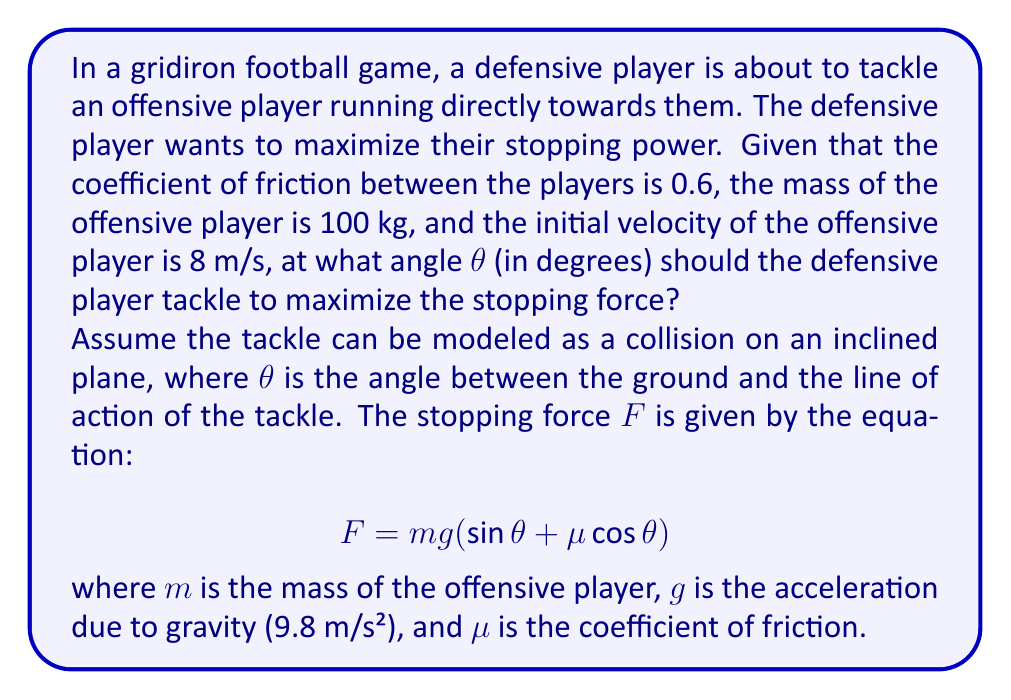Can you solve this math problem? To find the optimal angle for tackling, we need to maximize the stopping force F. We can do this by finding the angle θ where the derivative of F with respect to θ is zero.

Step 1: Express the force equation
$$ F = mg(\sin θ + μ \cos θ) $$

Step 2: Take the derivative of F with respect to θ
$$ \frac{dF}{dθ} = mg(\cos θ - μ \sin θ) $$

Step 3: Set the derivative to zero and solve for θ
$$ mg(\cos θ - μ \sin θ) = 0 $$
$$ \cos θ - μ \sin θ = 0 $$
$$ \cos θ = μ \sin θ $$
$$ \frac{\cos θ}{\sin θ} = μ $$
$$ \tan θ = \frac{1}{μ} $$

Step 4: Calculate the optimal angle
$$ θ = \arctan(\frac{1}{μ}) $$
$$ θ = \arctan(\frac{1}{0.6}) $$
$$ θ ≈ 59.04° $$

Step 5: Verify this is a maximum (not a minimum) by checking the second derivative
$$ \frac{d^2F}{dθ^2} = -mg(\sin θ + μ \cos θ) $$
At θ ≈ 59.04°, this is negative, confirming a maximum.

Therefore, the optimal angle for tackling to maximize stopping power is approximately 59.04 degrees.
Answer: 59.04° 